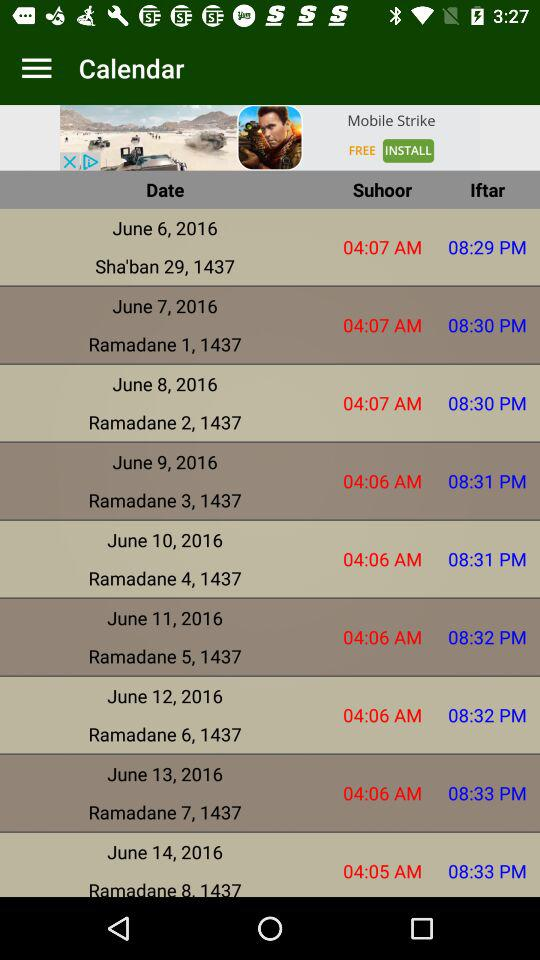What is the date for "Ramadane 7, 1437"? The date is June 13, 2016. 